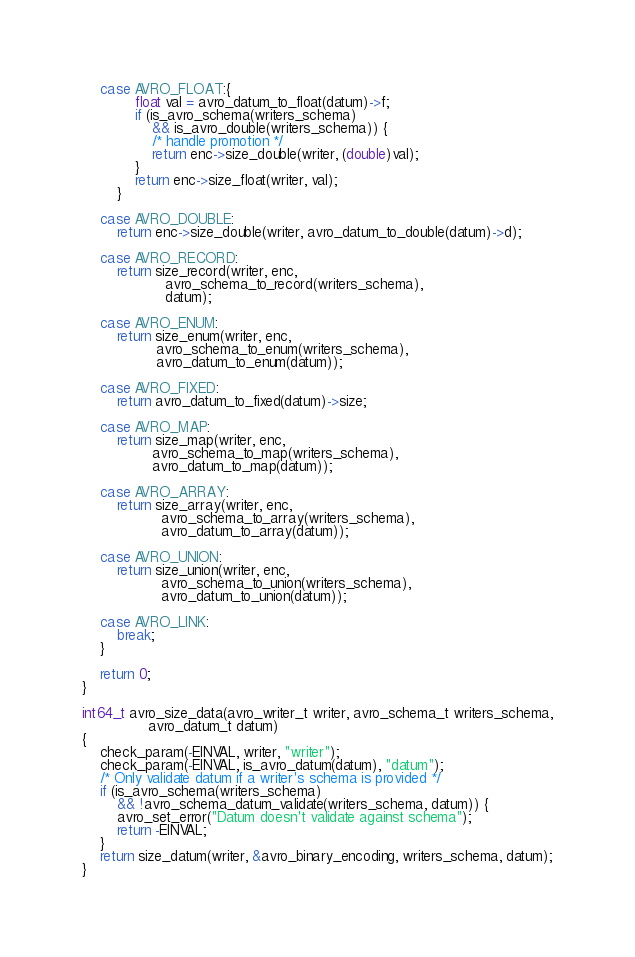Convert code to text. <code><loc_0><loc_0><loc_500><loc_500><_C_>
	case AVRO_FLOAT:{
			float val = avro_datum_to_float(datum)->f;
			if (is_avro_schema(writers_schema)
			    && is_avro_double(writers_schema)) {
				/* handle promotion */
				return enc->size_double(writer, (double)val);
			}
			return enc->size_float(writer, val);
		}

	case AVRO_DOUBLE:
		return enc->size_double(writer, avro_datum_to_double(datum)->d);

	case AVRO_RECORD:
		return size_record(writer, enc,
				   avro_schema_to_record(writers_schema),
				   datum);

	case AVRO_ENUM:
		return size_enum(writer, enc,
				 avro_schema_to_enum(writers_schema),
				 avro_datum_to_enum(datum));

	case AVRO_FIXED:
		return avro_datum_to_fixed(datum)->size;

	case AVRO_MAP:
		return size_map(writer, enc,
				avro_schema_to_map(writers_schema),
				avro_datum_to_map(datum));

	case AVRO_ARRAY:
		return size_array(writer, enc,
				  avro_schema_to_array(writers_schema),
				  avro_datum_to_array(datum));

	case AVRO_UNION:
		return size_union(writer, enc,
				  avro_schema_to_union(writers_schema),
				  avro_datum_to_union(datum));

	case AVRO_LINK:
		break;
	}

	return 0;
}

int64_t avro_size_data(avro_writer_t writer, avro_schema_t writers_schema,
		       avro_datum_t datum)
{
	check_param(-EINVAL, writer, "writer");
	check_param(-EINVAL, is_avro_datum(datum), "datum");
	/* Only validate datum if a writer's schema is provided */
	if (is_avro_schema(writers_schema)
	    && !avro_schema_datum_validate(writers_schema, datum)) {
		avro_set_error("Datum doesn't validate against schema");
		return -EINVAL;
	}
	return size_datum(writer, &avro_binary_encoding, writers_schema, datum);
}
</code> 